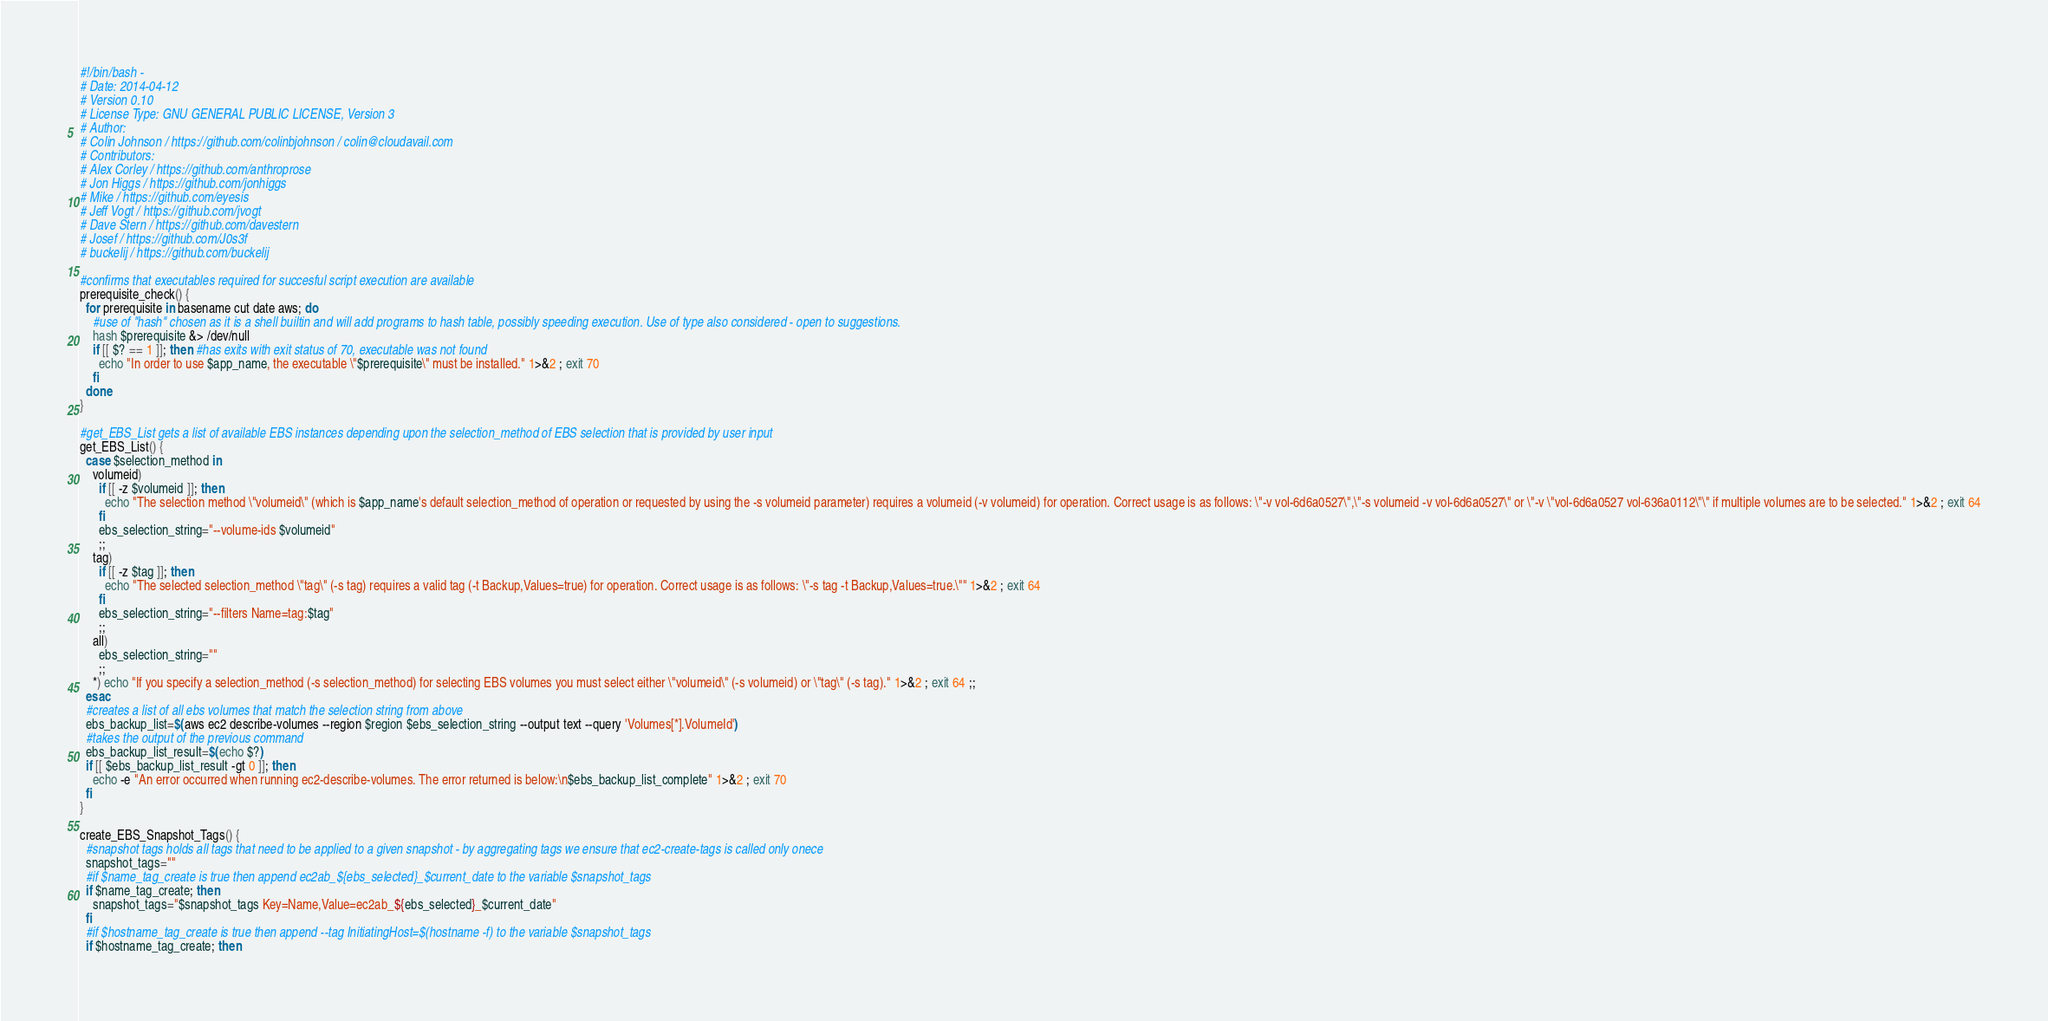Convert code to text. <code><loc_0><loc_0><loc_500><loc_500><_Bash_>#!/bin/bash -
# Date: 2014-04-12
# Version 0.10
# License Type: GNU GENERAL PUBLIC LICENSE, Version 3
# Author:
# Colin Johnson / https://github.com/colinbjohnson / colin@cloudavail.com
# Contributors:
# Alex Corley / https://github.com/anthroprose
# Jon Higgs / https://github.com/jonhiggs
# Mike / https://github.com/eyesis
# Jeff Vogt / https://github.com/jvogt
# Dave Stern / https://github.com/davestern
# Josef / https://github.com/J0s3f
# buckelij / https://github.com/buckelij

#confirms that executables required for succesful script execution are available
prerequisite_check() {
  for prerequisite in basename cut date aws; do
    #use of "hash" chosen as it is a shell builtin and will add programs to hash table, possibly speeding execution. Use of type also considered - open to suggestions.
    hash $prerequisite &> /dev/null
    if [[ $? == 1 ]]; then #has exits with exit status of 70, executable was not found
      echo "In order to use $app_name, the executable \"$prerequisite\" must be installed." 1>&2 ; exit 70
    fi
  done
}

#get_EBS_List gets a list of available EBS instances depending upon the selection_method of EBS selection that is provided by user input
get_EBS_List() {
  case $selection_method in
    volumeid)
      if [[ -z $volumeid ]]; then
        echo "The selection method \"volumeid\" (which is $app_name's default selection_method of operation or requested by using the -s volumeid parameter) requires a volumeid (-v volumeid) for operation. Correct usage is as follows: \"-v vol-6d6a0527\",\"-s volumeid -v vol-6d6a0527\" or \"-v \"vol-6d6a0527 vol-636a0112\"\" if multiple volumes are to be selected." 1>&2 ; exit 64
      fi
      ebs_selection_string="--volume-ids $volumeid"
      ;;
    tag)
      if [[ -z $tag ]]; then
        echo "The selected selection_method \"tag\" (-s tag) requires a valid tag (-t Backup,Values=true) for operation. Correct usage is as follows: \"-s tag -t Backup,Values=true.\"" 1>&2 ; exit 64
      fi
      ebs_selection_string="--filters Name=tag:$tag"
      ;;
    all)
      ebs_selection_string=""
      ;;
    *) echo "If you specify a selection_method (-s selection_method) for selecting EBS volumes you must select either \"volumeid\" (-s volumeid) or \"tag\" (-s tag)." 1>&2 ; exit 64 ;;
  esac
  #creates a list of all ebs volumes that match the selection string from above
  ebs_backup_list=$(aws ec2 describe-volumes --region $region $ebs_selection_string --output text --query 'Volumes[*].VolumeId')
  #takes the output of the previous command 
  ebs_backup_list_result=$(echo $?)
  if [[ $ebs_backup_list_result -gt 0 ]]; then
    echo -e "An error occurred when running ec2-describe-volumes. The error returned is below:\n$ebs_backup_list_complete" 1>&2 ; exit 70
  fi
}

create_EBS_Snapshot_Tags() {
  #snapshot tags holds all tags that need to be applied to a given snapshot - by aggregating tags we ensure that ec2-create-tags is called only onece
  snapshot_tags=""
  #if $name_tag_create is true then append ec2ab_${ebs_selected}_$current_date to the variable $snapshot_tags
  if $name_tag_create; then
    snapshot_tags="$snapshot_tags Key=Name,Value=ec2ab_${ebs_selected}_$current_date"
  fi
  #if $hostname_tag_create is true then append --tag InitiatingHost=$(hostname -f) to the variable $snapshot_tags
  if $hostname_tag_create; then</code> 